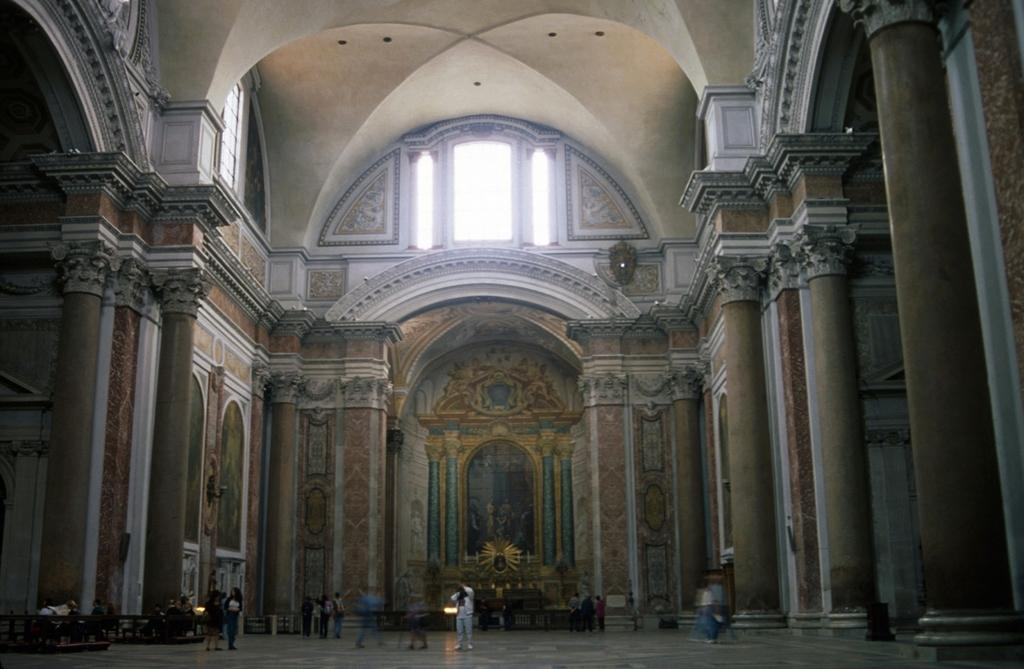What are the people in the image doing? The people in the image are walking. On what surface are the people walking? The people are walking on the floor. What architectural features can be seen in the image? There are pillars and a wall in the image. What can be seen in the background of the image? There are statues and ventilators in the background of the image. What type of shock can be seen in the image? There is no shock present in the image. 